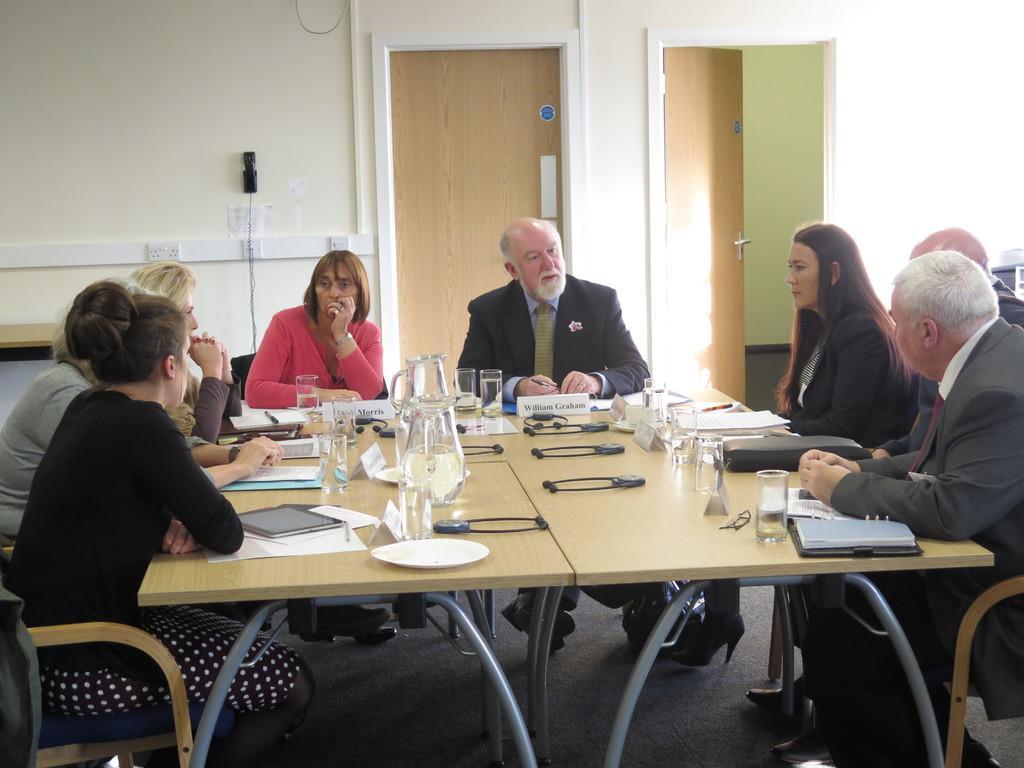Can you describe this image briefly? There are few people sitting on the chair at the table. On the table we can see books,plates,glass and jugs. On the wall we can see a phone. 